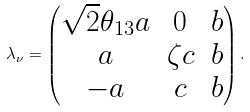Convert formula to latex. <formula><loc_0><loc_0><loc_500><loc_500>\lambda _ { \nu } = \begin{pmatrix} \sqrt { 2 } \theta _ { 1 3 } a & 0 & b \\ a & \zeta c & b \\ - a & c & b \end{pmatrix} .</formula> 